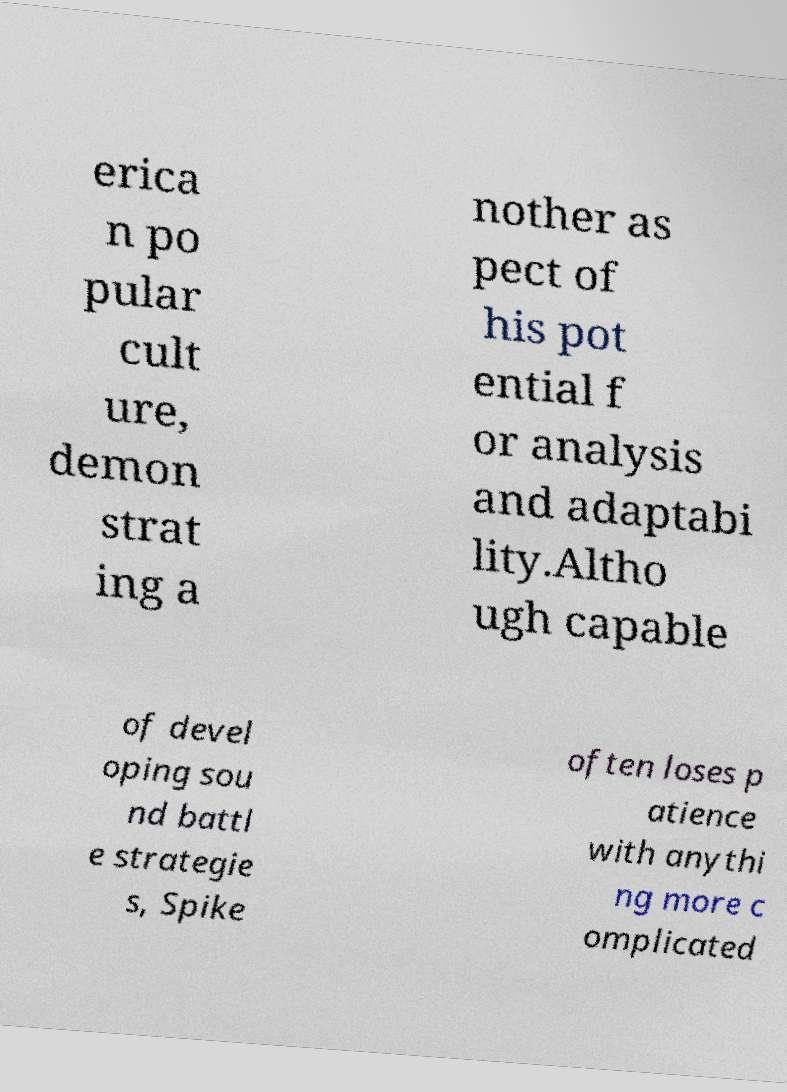Could you assist in decoding the text presented in this image and type it out clearly? erica n po pular cult ure, demon strat ing a nother as pect of his pot ential f or analysis and adaptabi lity.Altho ugh capable of devel oping sou nd battl e strategie s, Spike often loses p atience with anythi ng more c omplicated 